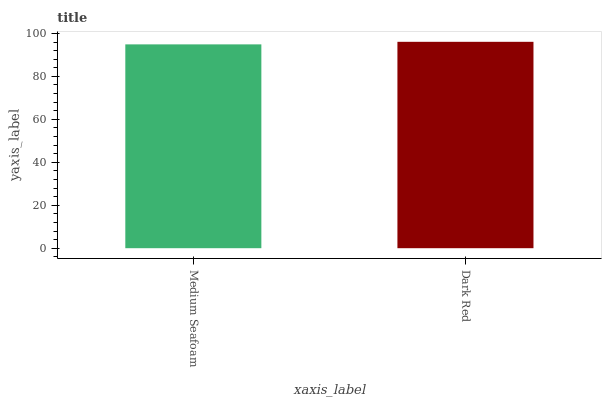Is Medium Seafoam the minimum?
Answer yes or no. Yes. Is Dark Red the maximum?
Answer yes or no. Yes. Is Dark Red the minimum?
Answer yes or no. No. Is Dark Red greater than Medium Seafoam?
Answer yes or no. Yes. Is Medium Seafoam less than Dark Red?
Answer yes or no. Yes. Is Medium Seafoam greater than Dark Red?
Answer yes or no. No. Is Dark Red less than Medium Seafoam?
Answer yes or no. No. Is Dark Red the high median?
Answer yes or no. Yes. Is Medium Seafoam the low median?
Answer yes or no. Yes. Is Medium Seafoam the high median?
Answer yes or no. No. Is Dark Red the low median?
Answer yes or no. No. 